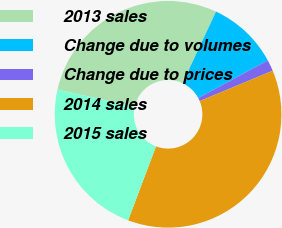Convert chart. <chart><loc_0><loc_0><loc_500><loc_500><pie_chart><fcel>2013 sales<fcel>Change due to volumes<fcel>Change due to prices<fcel>2014 sales<fcel>2015 sales<nl><fcel>28.45%<fcel>10.17%<fcel>1.6%<fcel>37.02%<fcel>22.77%<nl></chart> 